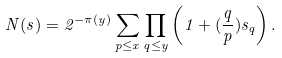<formula> <loc_0><loc_0><loc_500><loc_500>N ( s ) = 2 ^ { - \pi ( y ) } \sum _ { p \leq x } \prod _ { q \leq y } \left ( 1 + ( \frac { q } { p } ) s _ { q } \right ) .</formula> 